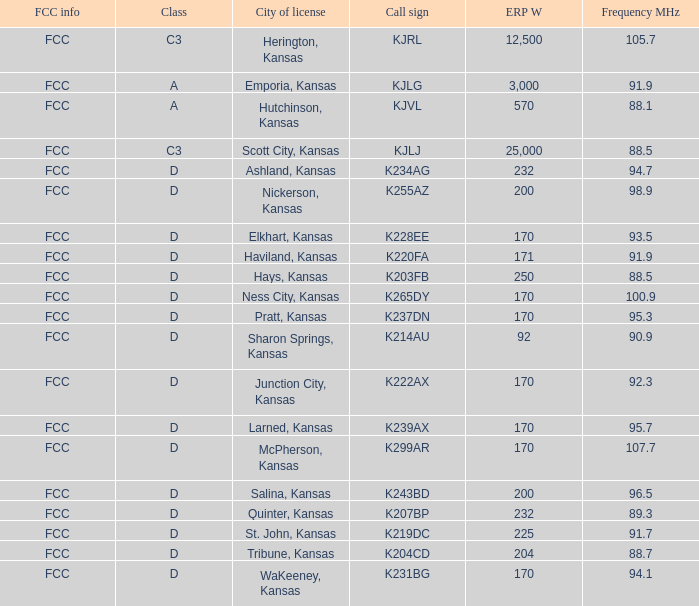Frequency MHz smaller than 95.3, and a Call sign of k234ag is what class? D. Write the full table. {'header': ['FCC info', 'Class', 'City of license', 'Call sign', 'ERP W', 'Frequency MHz'], 'rows': [['FCC', 'C3', 'Herington, Kansas', 'KJRL', '12,500', '105.7'], ['FCC', 'A', 'Emporia, Kansas', 'KJLG', '3,000', '91.9'], ['FCC', 'A', 'Hutchinson, Kansas', 'KJVL', '570', '88.1'], ['FCC', 'C3', 'Scott City, Kansas', 'KJLJ', '25,000', '88.5'], ['FCC', 'D', 'Ashland, Kansas', 'K234AG', '232', '94.7'], ['FCC', 'D', 'Nickerson, Kansas', 'K255AZ', '200', '98.9'], ['FCC', 'D', 'Elkhart, Kansas', 'K228EE', '170', '93.5'], ['FCC', 'D', 'Haviland, Kansas', 'K220FA', '171', '91.9'], ['FCC', 'D', 'Hays, Kansas', 'K203FB', '250', '88.5'], ['FCC', 'D', 'Ness City, Kansas', 'K265DY', '170', '100.9'], ['FCC', 'D', 'Pratt, Kansas', 'K237DN', '170', '95.3'], ['FCC', 'D', 'Sharon Springs, Kansas', 'K214AU', '92', '90.9'], ['FCC', 'D', 'Junction City, Kansas', 'K222AX', '170', '92.3'], ['FCC', 'D', 'Larned, Kansas', 'K239AX', '170', '95.7'], ['FCC', 'D', 'McPherson, Kansas', 'K299AR', '170', '107.7'], ['FCC', 'D', 'Salina, Kansas', 'K243BD', '200', '96.5'], ['FCC', 'D', 'Quinter, Kansas', 'K207BP', '232', '89.3'], ['FCC', 'D', 'St. John, Kansas', 'K219DC', '225', '91.7'], ['FCC', 'D', 'Tribune, Kansas', 'K204CD', '204', '88.7'], ['FCC', 'D', 'WaKeeney, Kansas', 'K231BG', '170', '94.1']]} 